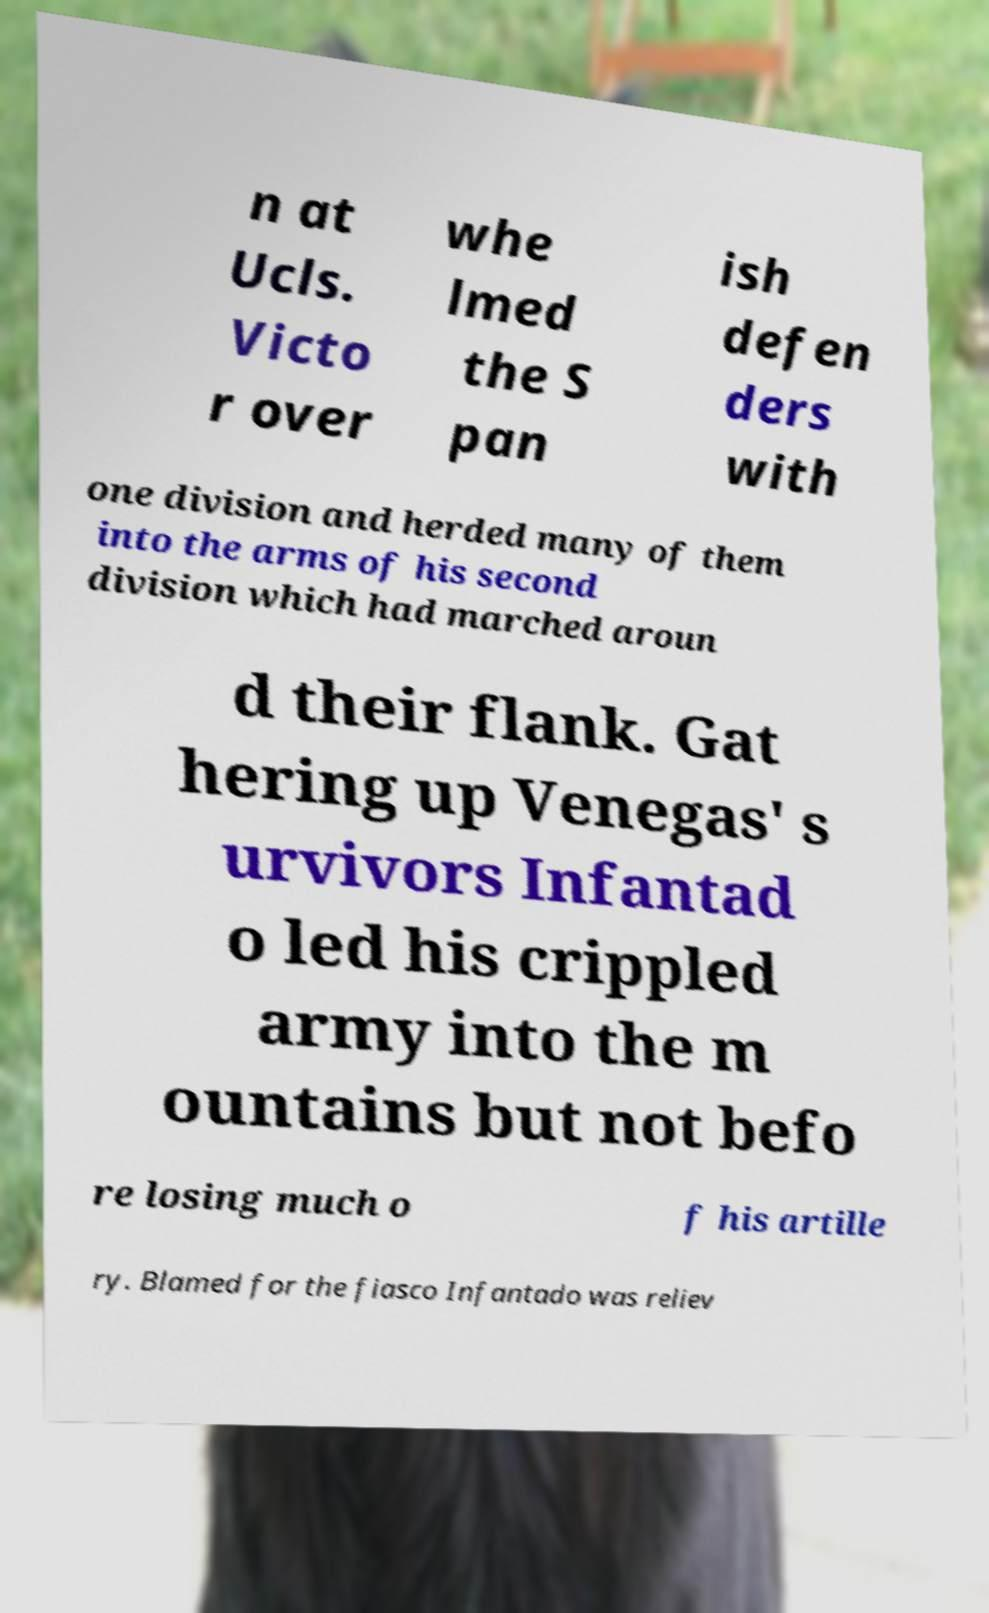There's text embedded in this image that I need extracted. Can you transcribe it verbatim? n at Ucls. Victo r over whe lmed the S pan ish defen ders with one division and herded many of them into the arms of his second division which had marched aroun d their flank. Gat hering up Venegas' s urvivors Infantad o led his crippled army into the m ountains but not befo re losing much o f his artille ry. Blamed for the fiasco Infantado was reliev 